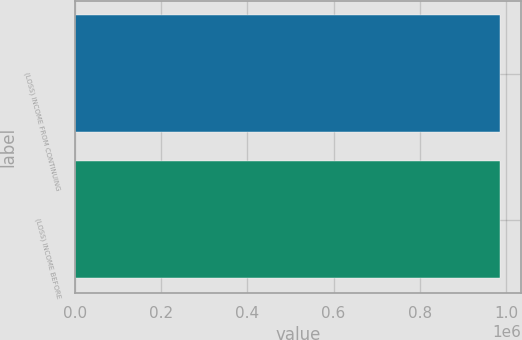<chart> <loc_0><loc_0><loc_500><loc_500><bar_chart><fcel>(LOSS) INCOME FROM CONTINUING<fcel>(LOSS) INCOME BEFORE<nl><fcel>984978<fcel>984978<nl></chart> 